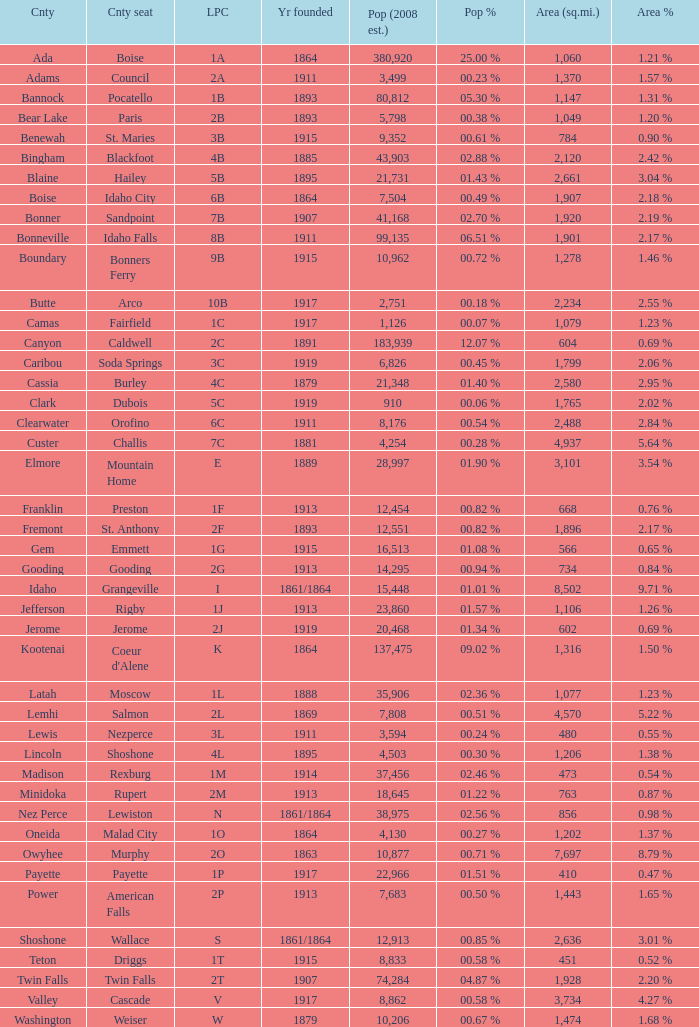What is the country seat for the license plate code 5c? Dubois. 